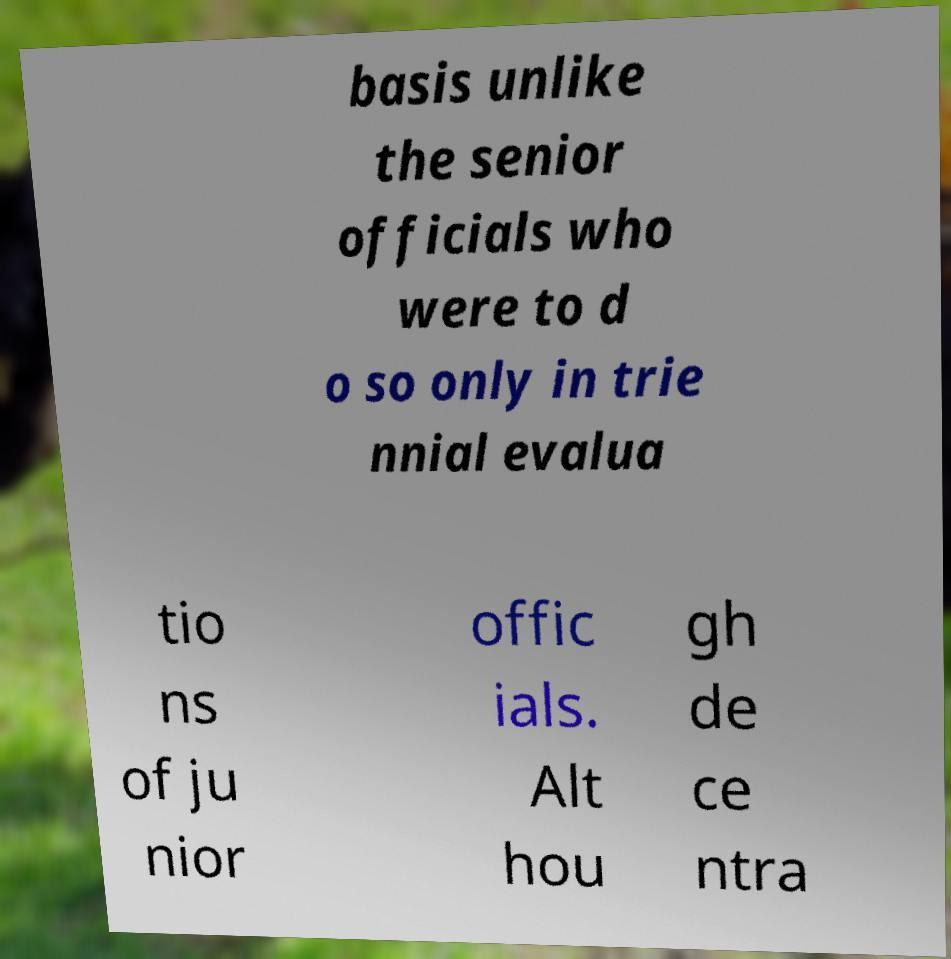Please read and relay the text visible in this image. What does it say? basis unlike the senior officials who were to d o so only in trie nnial evalua tio ns of ju nior offic ials. Alt hou gh de ce ntra 